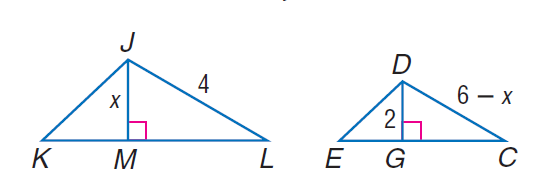Question: Find D C if D G and J M are altitudes and \triangle K J L \sim \triangle E D C.
Choices:
A. 2
B. 4
C. 6
D. 8
Answer with the letter. Answer: B 